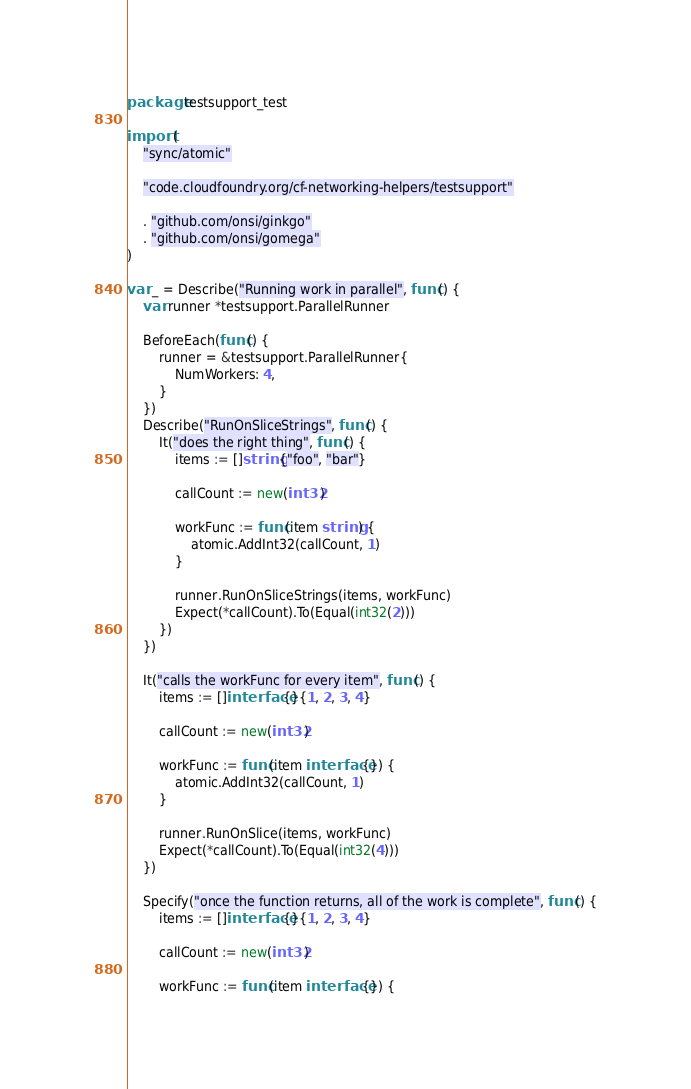Convert code to text. <code><loc_0><loc_0><loc_500><loc_500><_Go_>package testsupport_test

import (
	"sync/atomic"

	"code.cloudfoundry.org/cf-networking-helpers/testsupport"

	. "github.com/onsi/ginkgo"
	. "github.com/onsi/gomega"
)

var _ = Describe("Running work in parallel", func() {
	var runner *testsupport.ParallelRunner

	BeforeEach(func() {
		runner = &testsupport.ParallelRunner{
			NumWorkers: 4,
		}
	})
	Describe("RunOnSliceStrings", func() {
		It("does the right thing", func() {
			items := []string{"foo", "bar"}

			callCount := new(int32)

			workFunc := func(item string) {
				atomic.AddInt32(callCount, 1)
			}

			runner.RunOnSliceStrings(items, workFunc)
			Expect(*callCount).To(Equal(int32(2)))
		})
	})

	It("calls the workFunc for every item", func() {
		items := []interface{}{1, 2, 3, 4}

		callCount := new(int32)

		workFunc := func(item interface{}) {
			atomic.AddInt32(callCount, 1)
		}

		runner.RunOnSlice(items, workFunc)
		Expect(*callCount).To(Equal(int32(4)))
	})

	Specify("once the function returns, all of the work is complete", func() {
		items := []interface{}{1, 2, 3, 4}

		callCount := new(int32)

		workFunc := func(item interface{}) {</code> 